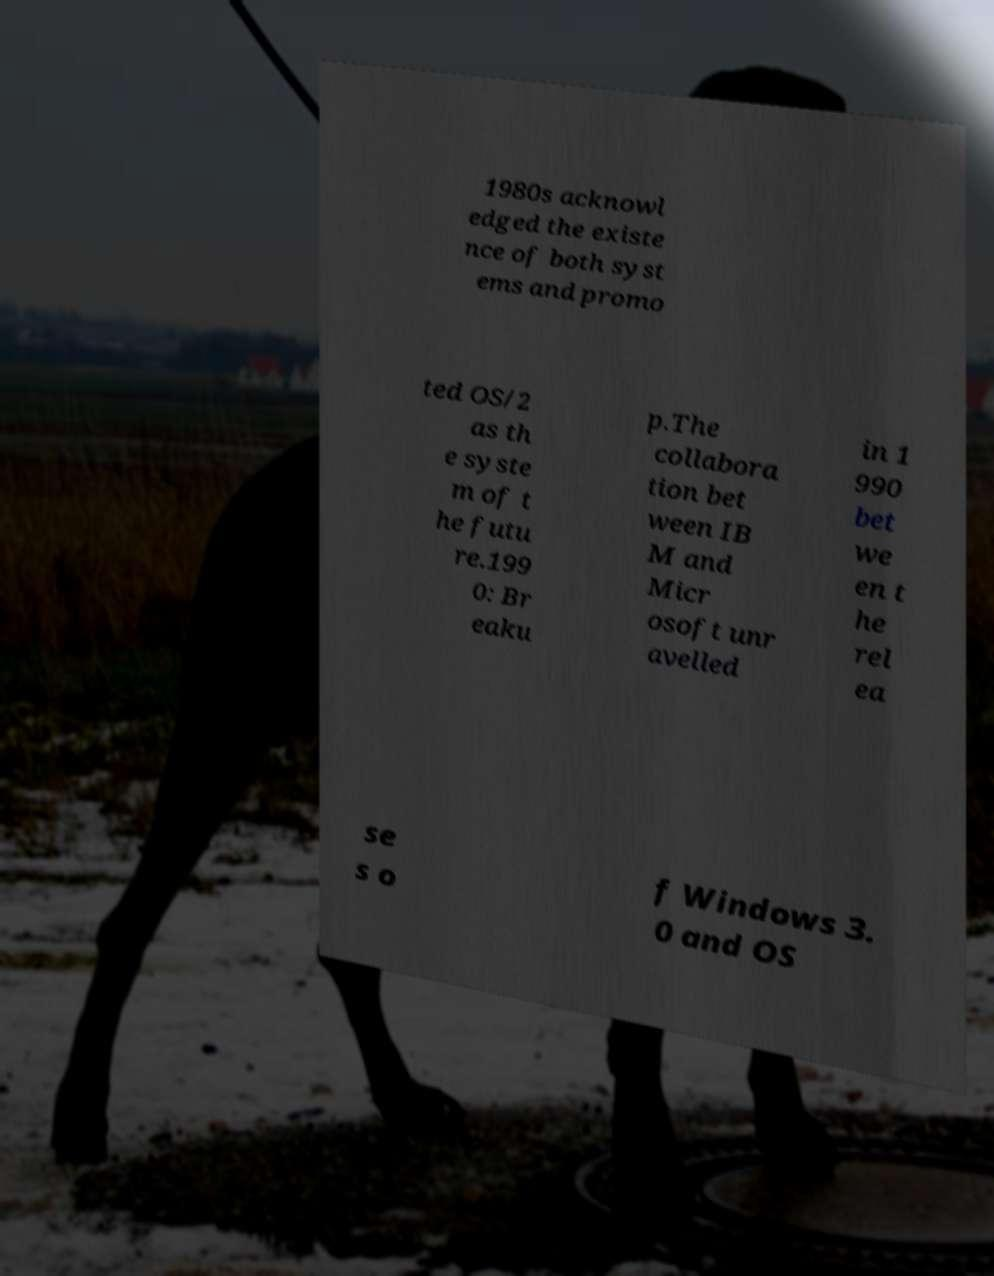I need the written content from this picture converted into text. Can you do that? 1980s acknowl edged the existe nce of both syst ems and promo ted OS/2 as th e syste m of t he futu re.199 0: Br eaku p.The collabora tion bet ween IB M and Micr osoft unr avelled in 1 990 bet we en t he rel ea se s o f Windows 3. 0 and OS 